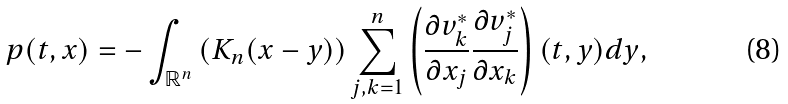Convert formula to latex. <formula><loc_0><loc_0><loc_500><loc_500>p ( t , x ) = - \int _ { { \mathbb { R } } ^ { n } } \left ( K _ { n } ( x - y ) \right ) \sum _ { j , k = 1 } ^ { n } \left ( \frac { \partial v ^ { * } _ { k } } { \partial x _ { j } } \frac { \partial v ^ { * } _ { j } } { \partial x _ { k } } \right ) ( t , y ) d y ,</formula> 